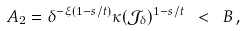Convert formula to latex. <formula><loc_0><loc_0><loc_500><loc_500>A _ { 2 } = \delta ^ { - \xi ( 1 - s / t ) } \kappa ( \mathcal { J _ { \delta } } ) ^ { 1 - s / t } \ < \ B \, ,</formula> 